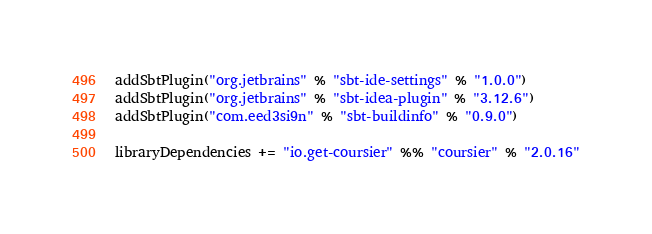Convert code to text. <code><loc_0><loc_0><loc_500><loc_500><_Scala_>addSbtPlugin("org.jetbrains" % "sbt-ide-settings" % "1.0.0")
addSbtPlugin("org.jetbrains" % "sbt-idea-plugin" % "3.12.6")
addSbtPlugin("com.eed3si9n" % "sbt-buildinfo" % "0.9.0")

libraryDependencies += "io.get-coursier" %% "coursier" % "2.0.16"
</code> 